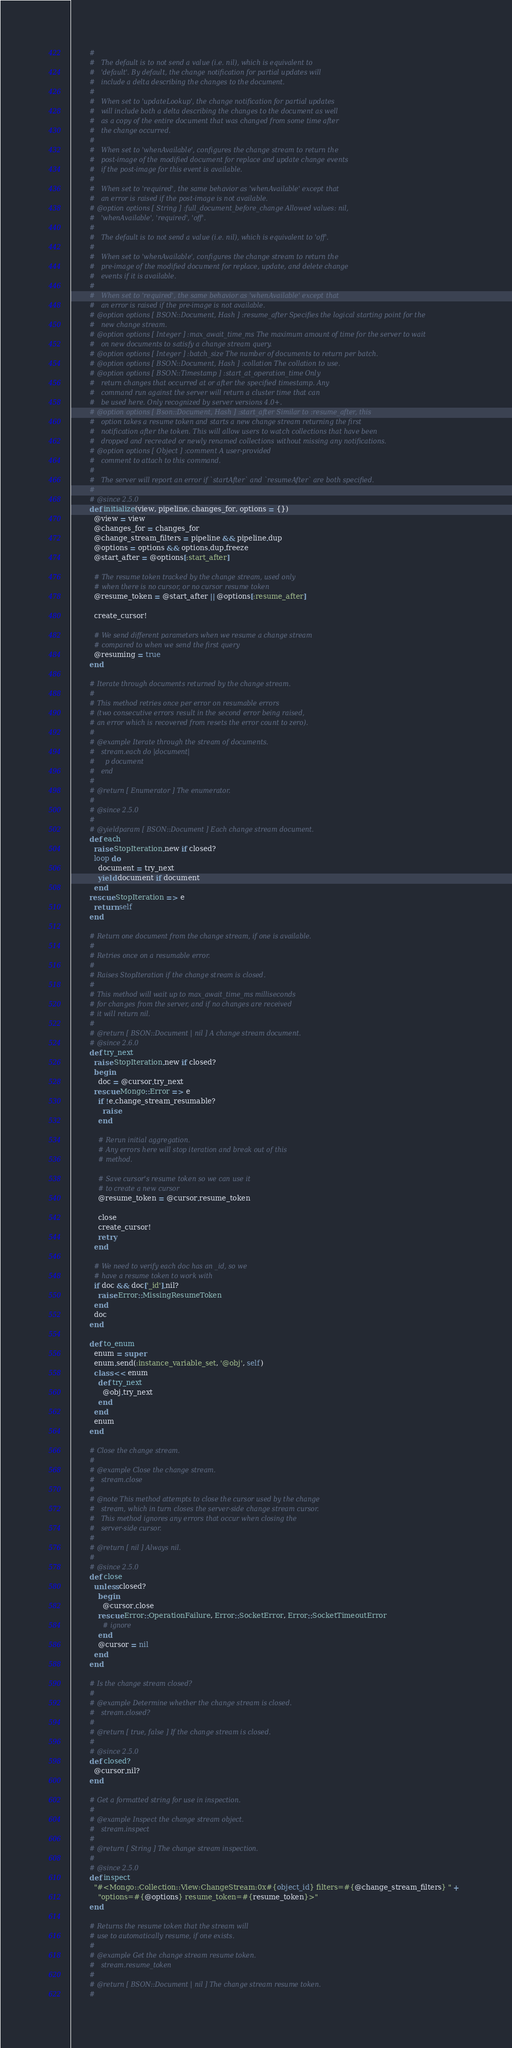Convert code to text. <code><loc_0><loc_0><loc_500><loc_500><_Ruby_>        #
        #   The default is to not send a value (i.e. nil), which is equivalent to
        #   'default'. By default, the change notification for partial updates will
        #   include a delta describing the changes to the document.
        #
        #   When set to 'updateLookup', the change notification for partial updates
        #   will include both a delta describing the changes to the document as well
        #   as a copy of the entire document that was changed from some time after
        #   the change occurred.
        #
        #   When set to 'whenAvailable', configures the change stream to return the
        #   post-image of the modified document for replace and update change events
        #   if the post-image for this event is available.
        #
        #   When set to 'required', the same behavior as 'whenAvailable' except that
        #   an error is raised if the post-image is not available.
        # @option options [ String ] :full_document_before_change Allowed values: nil,
        #   'whenAvailable', 'required', 'off'.
        #
        #   The default is to not send a value (i.e. nil), which is equivalent to 'off'.
        #
        #   When set to 'whenAvailable', configures the change stream to return the
        #   pre-image of the modified document for replace, update, and delete change
        #   events if it is available.
        #
        #   When set to 'required', the same behavior as 'whenAvailable' except that
        #   an error is raised if the pre-image is not available.
        # @option options [ BSON::Document, Hash ] :resume_after Specifies the logical starting point for the
        #   new change stream.
        # @option options [ Integer ] :max_await_time_ms The maximum amount of time for the server to wait
        #   on new documents to satisfy a change stream query.
        # @option options [ Integer ] :batch_size The number of documents to return per batch.
        # @option options [ BSON::Document, Hash ] :collation The collation to use.
        # @option options [ BSON::Timestamp ] :start_at_operation_time Only
        #   return changes that occurred at or after the specified timestamp. Any
        #   command run against the server will return a cluster time that can
        #   be used here. Only recognized by server versions 4.0+.
        # @option options [ Bson::Document, Hash ] :start_after Similar to :resume_after, this
        #   option takes a resume token and starts a new change stream returning the first
        #   notification after the token. This will allow users to watch collections that have been
        #   dropped and recreated or newly renamed collections without missing any notifications.
        # @option options [ Object ] :comment A user-provided
        #   comment to attach to this command.
        #
        #   The server will report an error if `startAfter` and `resumeAfter` are both specified.
        #
        # @since 2.5.0
        def initialize(view, pipeline, changes_for, options = {})
          @view = view
          @changes_for = changes_for
          @change_stream_filters = pipeline && pipeline.dup
          @options = options && options.dup.freeze
          @start_after = @options[:start_after]

          # The resume token tracked by the change stream, used only
          # when there is no cursor, or no cursor resume token
          @resume_token = @start_after || @options[:resume_after]

          create_cursor!

          # We send different parameters when we resume a change stream
          # compared to when we send the first query
          @resuming = true
        end

        # Iterate through documents returned by the change stream.
        #
        # This method retries once per error on resumable errors
        # (two consecutive errors result in the second error being raised,
        # an error which is recovered from resets the error count to zero).
        #
        # @example Iterate through the stream of documents.
        #   stream.each do |document|
        #     p document
        #   end
        #
        # @return [ Enumerator ] The enumerator.
        #
        # @since 2.5.0
        #
        # @yieldparam [ BSON::Document ] Each change stream document.
        def each
          raise StopIteration.new if closed?
          loop do
            document = try_next
            yield document if document
          end
        rescue StopIteration => e
          return self
        end

        # Return one document from the change stream, if one is available.
        #
        # Retries once on a resumable error.
        #
        # Raises StopIteration if the change stream is closed.
        #
        # This method will wait up to max_await_time_ms milliseconds
        # for changes from the server, and if no changes are received
        # it will return nil.
        #
        # @return [ BSON::Document | nil ] A change stream document.
        # @since 2.6.0
        def try_next
          raise StopIteration.new if closed?
          begin
            doc = @cursor.try_next
          rescue Mongo::Error => e
            if !e.change_stream_resumable?
              raise
            end

            # Rerun initial aggregation.
            # Any errors here will stop iteration and break out of this
            # method.

            # Save cursor's resume token so we can use it
            # to create a new cursor
            @resume_token = @cursor.resume_token

            close
            create_cursor!
            retry
          end

          # We need to verify each doc has an _id, so we
          # have a resume token to work with
          if doc && doc['_id'].nil?
            raise Error::MissingResumeToken
          end
          doc
        end

        def to_enum
          enum = super
          enum.send(:instance_variable_set, '@obj', self)
          class << enum
            def try_next
              @obj.try_next
            end
          end
          enum
        end

        # Close the change stream.
        #
        # @example Close the change stream.
        #   stream.close
        #
        # @note This method attempts to close the cursor used by the change
        #   stream, which in turn closes the server-side change stream cursor.
        #   This method ignores any errors that occur when closing the
        #   server-side cursor.
        #
        # @return [ nil ] Always nil.
        #
        # @since 2.5.0
        def close
          unless closed?
            begin
              @cursor.close
            rescue Error::OperationFailure, Error::SocketError, Error::SocketTimeoutError
              # ignore
            end
            @cursor = nil
          end
        end

        # Is the change stream closed?
        #
        # @example Determine whether the change stream is closed.
        #   stream.closed?
        #
        # @return [ true, false ] If the change stream is closed.
        #
        # @since 2.5.0
        def closed?
          @cursor.nil?
        end

        # Get a formatted string for use in inspection.
        #
        # @example Inspect the change stream object.
        #   stream.inspect
        #
        # @return [ String ] The change stream inspection.
        #
        # @since 2.5.0
        def inspect
          "#<Mongo::Collection::View:ChangeStream:0x#{object_id} filters=#{@change_stream_filters} " +
            "options=#{@options} resume_token=#{resume_token}>"
        end

        # Returns the resume token that the stream will
        # use to automatically resume, if one exists.
        #
        # @example Get the change stream resume token.
        #   stream.resume_token
        #
        # @return [ BSON::Document | nil ] The change stream resume token.
        #</code> 